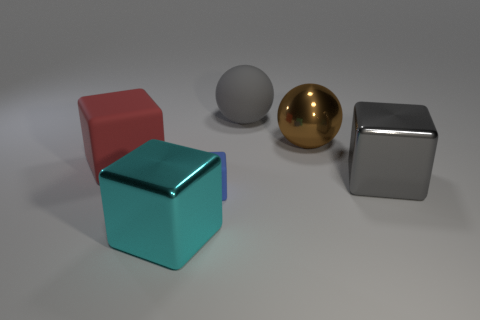How many big cubes are both to the left of the large gray matte ball and to the right of the red matte block?
Keep it short and to the point. 1. Is the number of large cubes that are on the right side of the large rubber block greater than the number of big cyan blocks that are right of the gray rubber sphere?
Make the answer very short. Yes. How big is the blue matte object?
Give a very brief answer. Small. Is there a blue thing that has the same shape as the cyan object?
Offer a terse response. Yes. Do the small object and the large gray thing behind the large gray metal object have the same shape?
Offer a very short reply. No. There is a cube that is right of the large cyan metallic object and to the left of the large brown ball; how big is it?
Keep it short and to the point. Small. What number of large cyan shiny cylinders are there?
Provide a short and direct response. 0. What is the material of the gray object that is the same size as the gray shiny block?
Offer a very short reply. Rubber. Are there any brown shiny things of the same size as the gray shiny block?
Your answer should be compact. Yes. There is a metallic block behind the tiny rubber cube; does it have the same color as the rubber object that is to the right of the small rubber object?
Offer a terse response. Yes. 